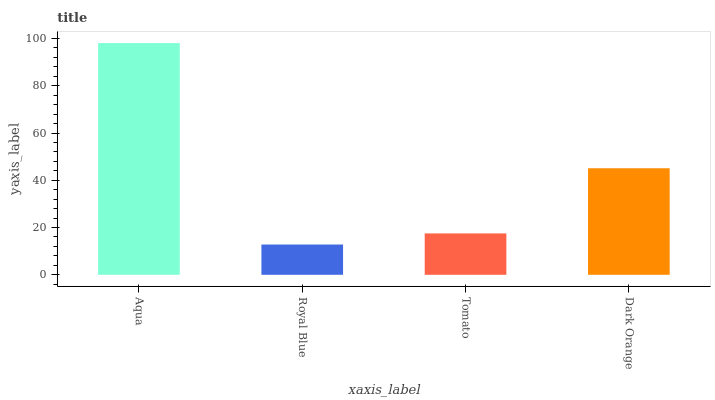Is Royal Blue the minimum?
Answer yes or no. Yes. Is Aqua the maximum?
Answer yes or no. Yes. Is Tomato the minimum?
Answer yes or no. No. Is Tomato the maximum?
Answer yes or no. No. Is Tomato greater than Royal Blue?
Answer yes or no. Yes. Is Royal Blue less than Tomato?
Answer yes or no. Yes. Is Royal Blue greater than Tomato?
Answer yes or no. No. Is Tomato less than Royal Blue?
Answer yes or no. No. Is Dark Orange the high median?
Answer yes or no. Yes. Is Tomato the low median?
Answer yes or no. Yes. Is Tomato the high median?
Answer yes or no. No. Is Aqua the low median?
Answer yes or no. No. 